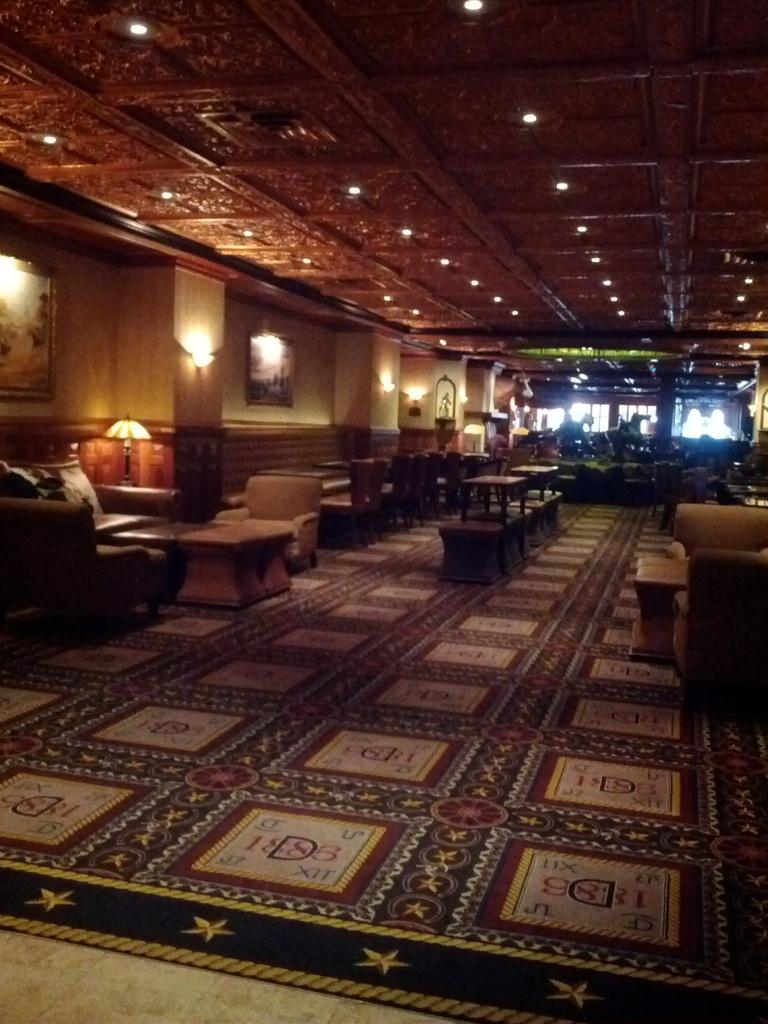What type of space is shown in the image? The image depicts a big hall. What furniture is present in the hall? There are chairs and tables in the hall. What type of lighting is available in the hall? Roof lamps are present in the hall. What language is being spoken by the laborer in the image? There is no laborer or spoken language present in the image. 